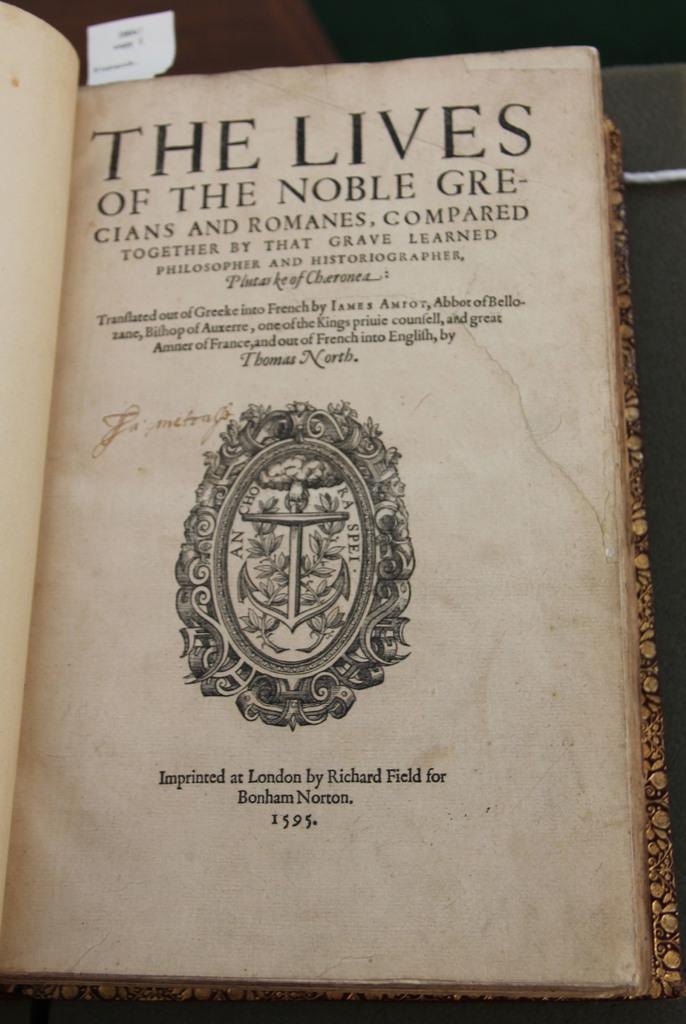<image>
Write a terse but informative summary of the picture. a book called The Lives of the Noble Grecians 